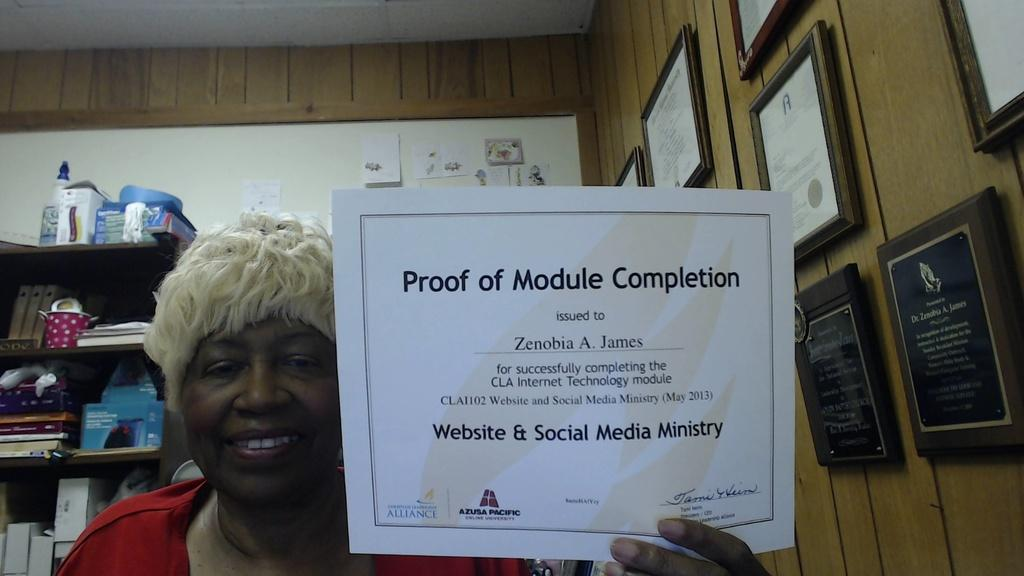<image>
Relay a brief, clear account of the picture shown. a lady holding her proof of module completion certificate 